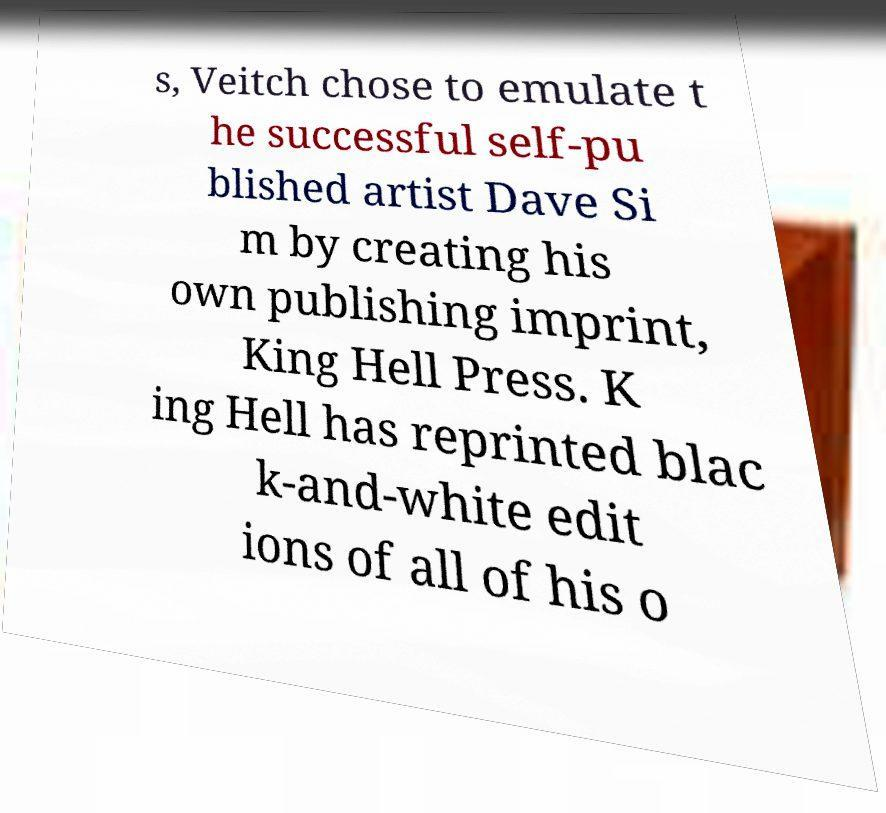Can you accurately transcribe the text from the provided image for me? s, Veitch chose to emulate t he successful self-pu blished artist Dave Si m by creating his own publishing imprint, King Hell Press. K ing Hell has reprinted blac k-and-white edit ions of all of his o 